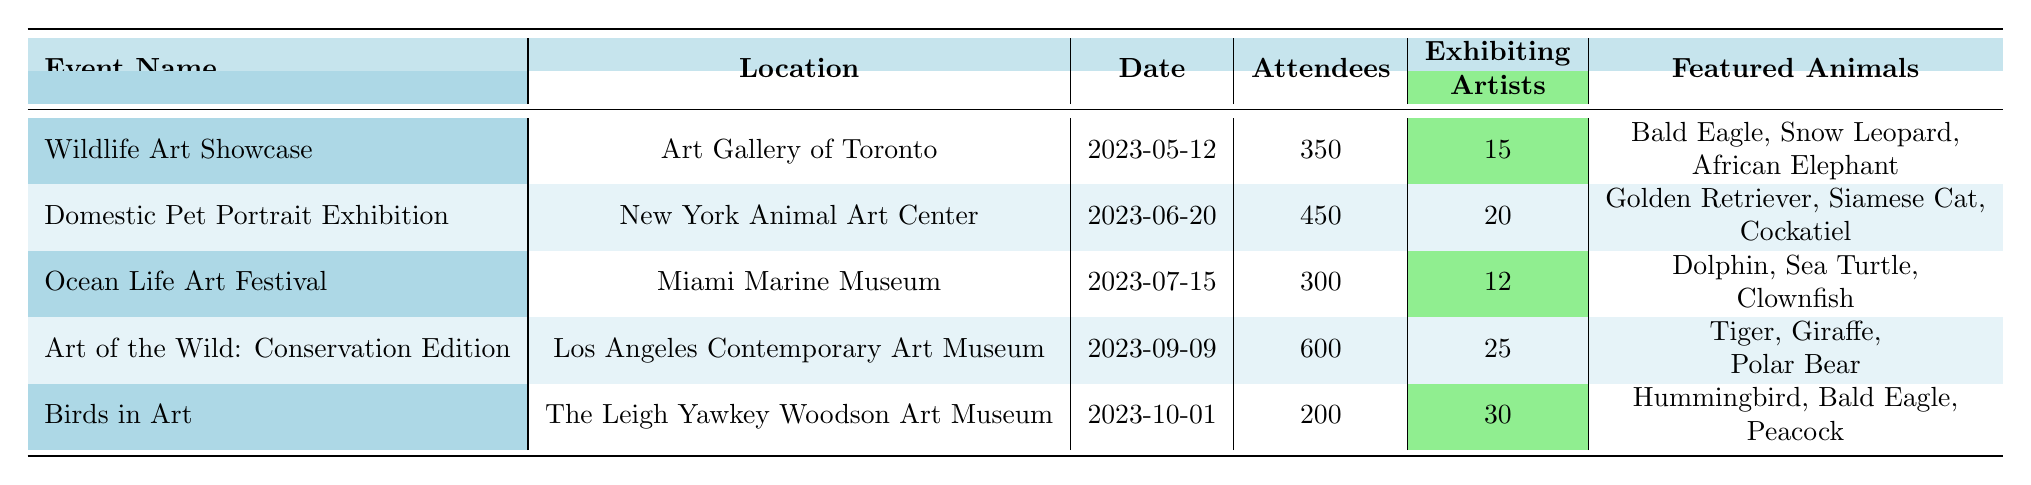What is the total number of attendees across all exhibitions? To find the total number of attendees, we add the attendees from each event: 350 + 450 + 300 + 600 + 200 = 1900.
Answer: 1900 Which exhibition had the highest number of exhibiting artists? By checking the "Exhibiting Artists" column, "Birds in Art" has 30 exhibiting artists, which is more than any other event.
Answer: Birds in Art How many more attendees were at the "Art of the Wild: Conservation Edition" than the "Ocean Life Art Festival"? We calculate the difference by subtracting the attendees of the "Ocean Life Art Festival" (300) from the "Art of the Wild: Conservation Edition" (600): 600 - 300 = 300.
Answer: 300 What percentage of the total attendees was present at the "Domestic Pet Portrait Exhibition"? First, we established the total attendees as 1900. The attendees for this exhibition are 450. We find the percentage: (450 / 1900) × 100 = 23.68%.
Answer: 23.68% Did the "Wildlife Art Showcase" feature a Bald Eagle? Checking the list of featured animals for "Wildlife Art Showcase," it includes the Bald Eagle, therefore the answer is yes.
Answer: Yes How many exhibitions had more than 400 attendees? By examining the "Attendees" column: "Domestic Pet Portrait Exhibition" (450), "Art of the Wild: Conservation Edition" (600) are both over 400. Thus, there are 2 exhibitions.
Answer: 2 What is the average number of attendees per exhibition? To find the average, we divide the total number of attendees (1900) by the number of exhibitions (5): 1900 / 5 = 380.
Answer: 380 Which event had the least number of attendees, and how many were there? "Birds in Art" is the event with the least attendees at 200, according to the "Attendees" column.
Answer: Birds in Art, 200 How many different animals were featured across all exhibitions? By listing animals from each event, we calculate: 3 from each of the 5 exhibitions, totaling 15 different animals featured.
Answer: 15 Which events featured the Tiger or Giraffe? Examining the list of featured animals, the "Art of the Wild: Conservation Edition" includes both the Tiger and Giraffe.
Answer: Art of the Wild: Conservation Edition 